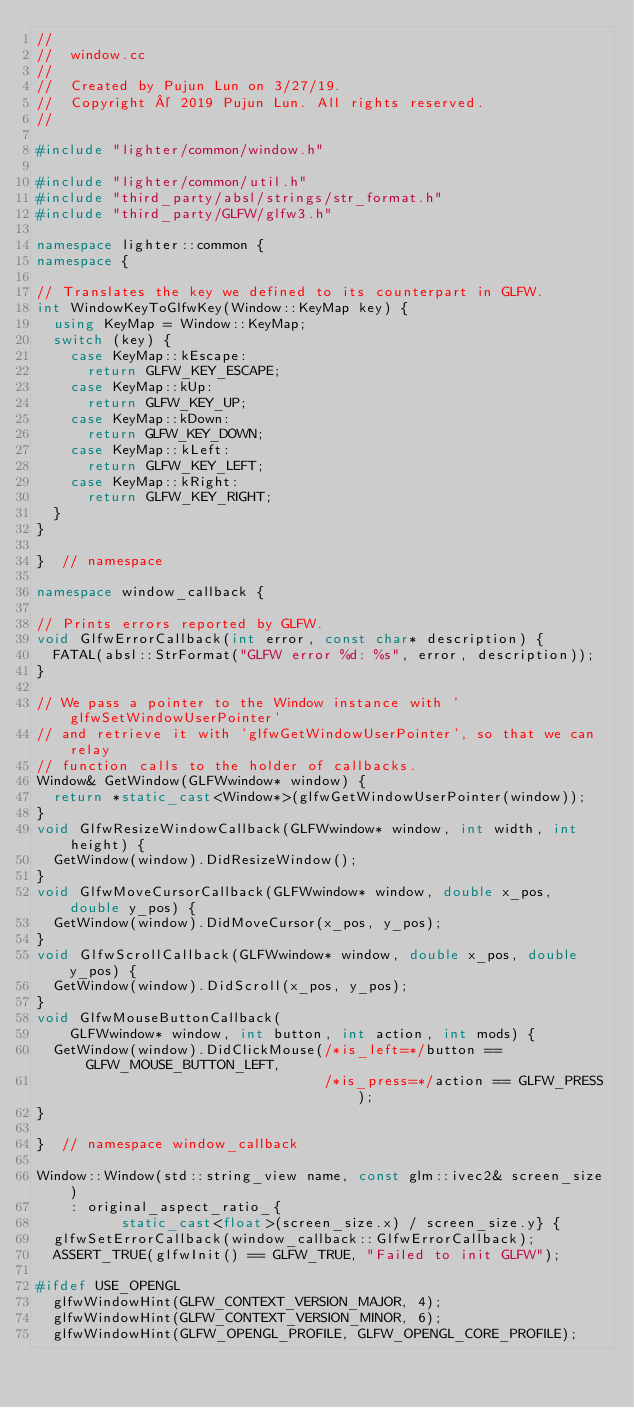Convert code to text. <code><loc_0><loc_0><loc_500><loc_500><_C++_>//
//  window.cc
//
//  Created by Pujun Lun on 3/27/19.
//  Copyright © 2019 Pujun Lun. All rights reserved.
//

#include "lighter/common/window.h"

#include "lighter/common/util.h"
#include "third_party/absl/strings/str_format.h"
#include "third_party/GLFW/glfw3.h"

namespace lighter::common {
namespace {

// Translates the key we defined to its counterpart in GLFW.
int WindowKeyToGlfwKey(Window::KeyMap key) {
  using KeyMap = Window::KeyMap;
  switch (key) {
    case KeyMap::kEscape:
      return GLFW_KEY_ESCAPE;
    case KeyMap::kUp:
      return GLFW_KEY_UP;
    case KeyMap::kDown:
      return GLFW_KEY_DOWN;
    case KeyMap::kLeft:
      return GLFW_KEY_LEFT;
    case KeyMap::kRight:
      return GLFW_KEY_RIGHT;
  }
}

}  // namespace

namespace window_callback {

// Prints errors reported by GLFW.
void GlfwErrorCallback(int error, const char* description) {
  FATAL(absl::StrFormat("GLFW error %d: %s", error, description));
}

// We pass a pointer to the Window instance with 'glfwSetWindowUserPointer'
// and retrieve it with 'glfwGetWindowUserPointer', so that we can relay
// function calls to the holder of callbacks.
Window& GetWindow(GLFWwindow* window) {
  return *static_cast<Window*>(glfwGetWindowUserPointer(window));
}
void GlfwResizeWindowCallback(GLFWwindow* window, int width, int height) {
  GetWindow(window).DidResizeWindow();
}
void GlfwMoveCursorCallback(GLFWwindow* window, double x_pos, double y_pos) {
  GetWindow(window).DidMoveCursor(x_pos, y_pos);
}
void GlfwScrollCallback(GLFWwindow* window, double x_pos, double y_pos) {
  GetWindow(window).DidScroll(x_pos, y_pos);
}
void GlfwMouseButtonCallback(
    GLFWwindow* window, int button, int action, int mods) {
  GetWindow(window).DidClickMouse(/*is_left=*/button == GLFW_MOUSE_BUTTON_LEFT,
                                  /*is_press=*/action == GLFW_PRESS);
}

}  // namespace window_callback

Window::Window(std::string_view name, const glm::ivec2& screen_size)
    : original_aspect_ratio_{
          static_cast<float>(screen_size.x) / screen_size.y} {
  glfwSetErrorCallback(window_callback::GlfwErrorCallback);
  ASSERT_TRUE(glfwInit() == GLFW_TRUE, "Failed to init GLFW");

#ifdef USE_OPENGL
  glfwWindowHint(GLFW_CONTEXT_VERSION_MAJOR, 4);
  glfwWindowHint(GLFW_CONTEXT_VERSION_MINOR, 6);
  glfwWindowHint(GLFW_OPENGL_PROFILE, GLFW_OPENGL_CORE_PROFILE);</code> 